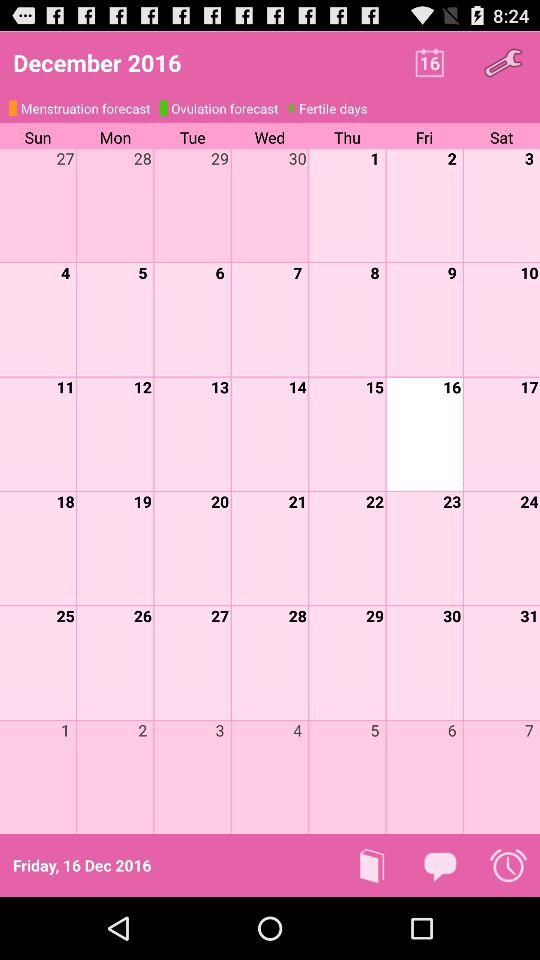What is the year? The year is 2016. 